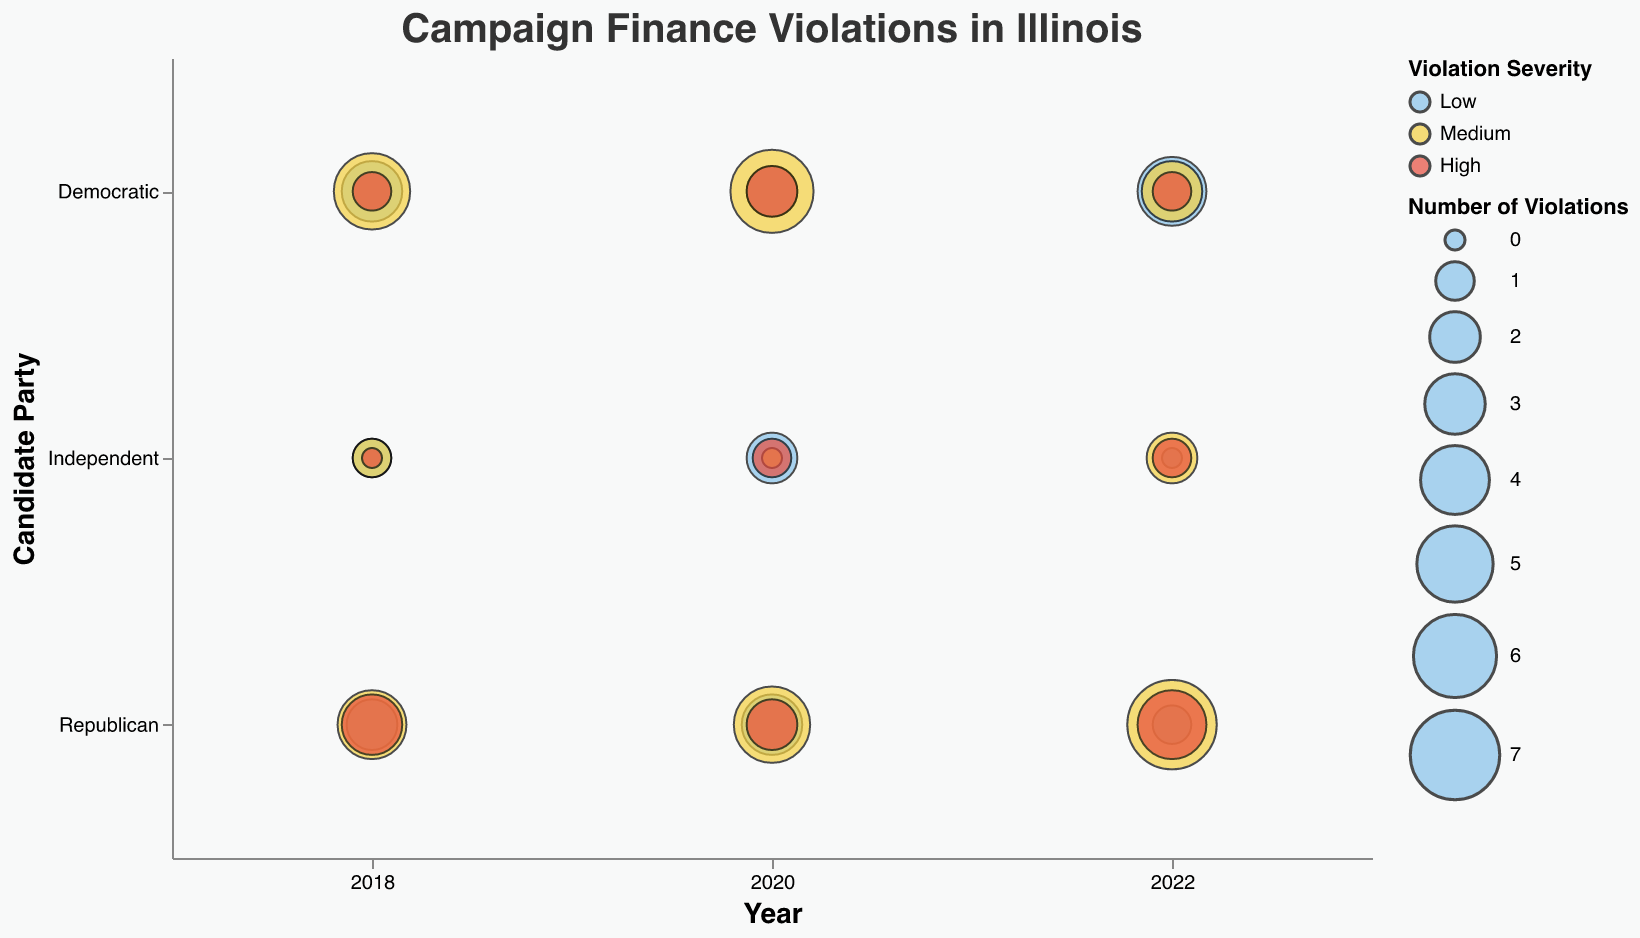What is the title of the chart? The title is typically at the top of the chart, making it easy to identify. The title here is "Campaign Finance Violations in Illinois"
Answer: Campaign Finance Violations in Illinois Which candidate party had the highest number of high severity violations in 2022? Look for the bubbles with "High" severity in 2022 and compare their sizes for each candidate party. The largest bubble in this category belongs to the Republican party.
Answer: Republican How many low severity violations did Democratic candidates have in 2020? Locate the bubble for the Democratic party in 2020 with "Low" severity and check its size, representing the number of violations.
Answer: 2 Compare the number of medium severity violations between Democrats and Republicans in 2018. Which party had more violations? Determine the size of the bubbles with "Medium" severity for Democrats and Republicans in 2018. Democrats had 5 violations, while Republicans had 4. Therefore, Democrats had more violations.
Answer: Democratic For the Independent party, compare the number of low severity violations between 2018 and 2020. Find and compare the sizes of the "Low" severity bubbles for the Independent party in 2018 and 2020. In 2018, there was 1 violation, and in 2020, there were 2 violations. So, there were more in 2020.
Answer: 2020 What is the trend for the number of medium severity violations for Republicans from 2018 to 2022? Observe the bubble size for "Medium" severity violations for Republicans over the years 2018, 2020, and 2022. The count increased from 4 in 2018 to 5 in 2020 and 7 in 2022, showing an increasing trend.
Answer: Increasing Which candidate party has the least number of violations in 2022? Compare the total sizes of all bubbles for each candidate party in 2022. The Independent party has the least number of violations.
Answer: Independent How does the number of high severity violations for Independent candidates in 2018 and 2022 compare? Check the sizes of the "High" severity bubbles for Independent candidates in 2018 (0 violations) and 2022 (1 violation).
Answer: The number increased from 0 to 1 Which year had the highest total number of violations for Republican candidates? Sum the sizes of all bubbles for Republican candidates for each year and compare. Total violations in 2018 = 2 + 4 + 3 = 9, in 2020 = 3 + 5 + 2 = 10, in 2022 = 1 + 7 + 4 = 12. The highest total is in 2022.
Answer: 2022 